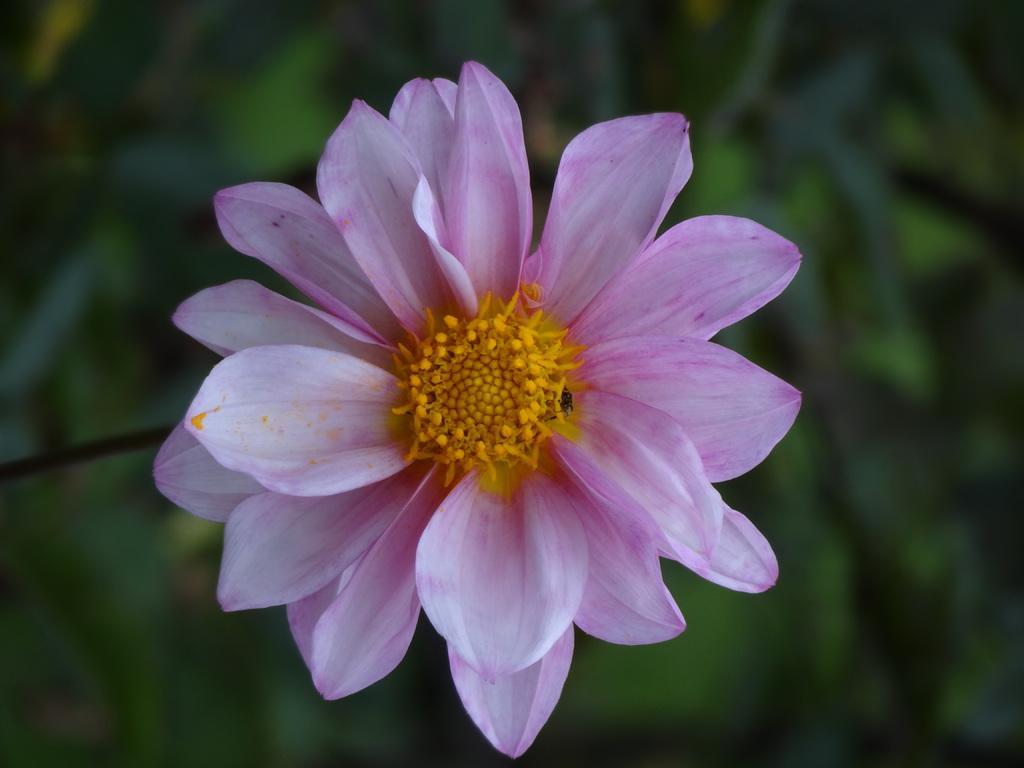In one or two sentences, can you explain what this image depicts? In the center of the picture there is a flower. The background is blurred. 